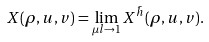<formula> <loc_0><loc_0><loc_500><loc_500>X ( \rho , u , v ) = \lim _ { \mu l \to 1 } X ^ { \bar { h } } ( \rho , u , v ) .</formula> 